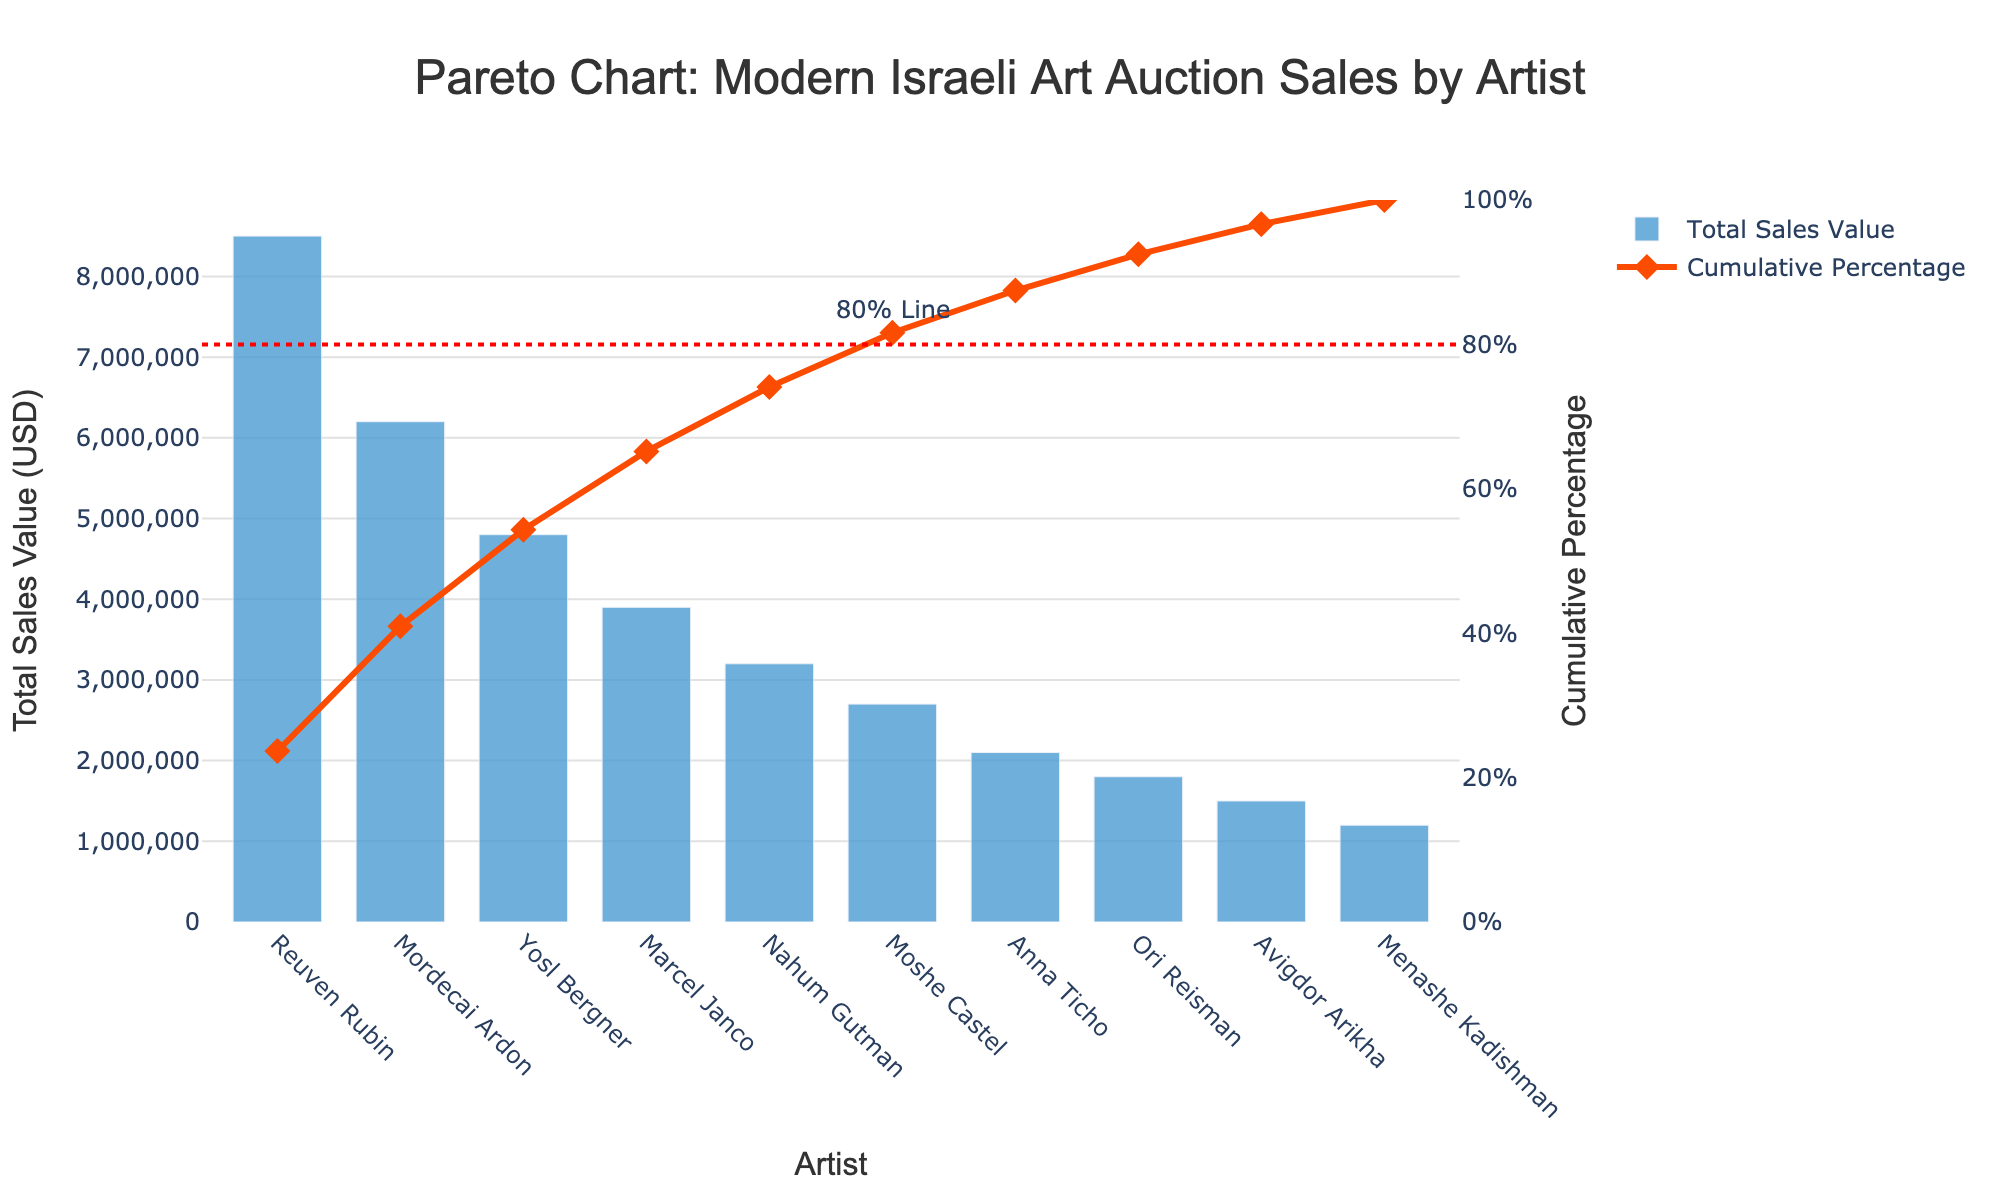What is the title of the chart? The title is displayed at the top of the chart and reads "Pareto Chart: Modern Israeli Art Auction Sales by Artist."
Answer: Pareto Chart: Modern Israeli Art Auction Sales by Artist Which artist has the highest total sales value? The highest bar on the chart represents the artist with the highest total sales value, which is Reuven Rubin.
Answer: Reuven Rubin What is the total sales value for Nahum Gutman? Nahum Gutman's position on the x-axis correlates with a bar that indicates he has a total sales value of $3,200,000.
Answer: $3,200,000 How many artists have a cumulative percentage of sales of at least 80%? The red dotted line marks the 80% cumulative percentage on the secondary y-axis, and artists up to Nahum Gutman contribute to reaching and surpassing this line.
Answer: 5 artists What is the cumulative percentage of sales after including Marcel Janco? Checking the value on the secondary y-axis for Marcel Janco shows a cumulative percentage slightly above 70%.
Answer: ~71.5% What is the difference in total sales value between Reuven Rubin and Mordecai Ardon? Reuven Rubin's sales value is $8,500,000, and Mordecai Ardon's is $6,200,000. The difference is $8,500,000 - $6,200,000.
Answer: $2,300,000 Which artist's total sales value adds up to be exactly 10,000,000 when combined with Menashe Kadishman's sales? Menashe Kadishman's sales value is $1,200,000. Adding Yosl Bergner's sales value of $4,800,000 results in a total of less than $10 million, but adding Anna Ticho's $2,100,000 gives $3,300,000, falling short. The correct artist is Nahum Gutman, with $3,200,000 added to Menashe Kadishman's yielding exactly $10,000,000.
Answer: Nahum Gutman Which artist’s bar color indicates the sales value and how does it differ from the color of the cumulative percentage line? The bar indicating sales value is blue, while the line indicating cumulative percentage is an orange-red color.
Answer: Blue vs. Orange-red What is the sales value of Ori Reisman? The bar corresponding to Ori Reisman indicates a sales value of $1,800,000.
Answer: $1,800,000 How many artists have total sales values below $2,000,000? Artists with bars representing values below the $2,000,000 mark on the y-axis are Anna Ticho, Ori Reisman, Avigdor Arikha, and Menashe Kadishman.
Answer: 4 artists 